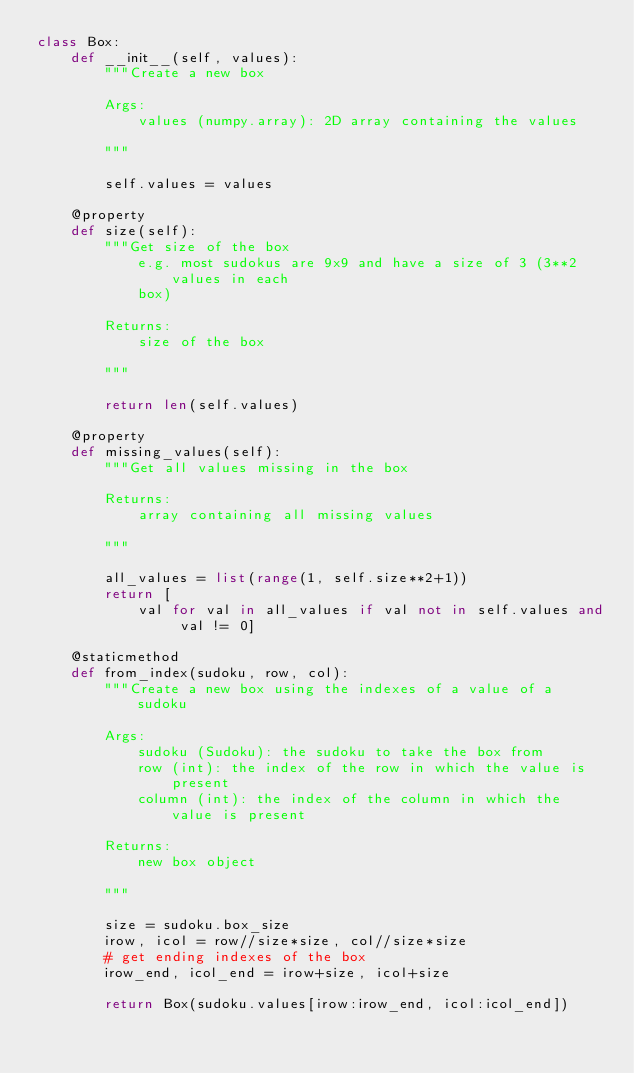<code> <loc_0><loc_0><loc_500><loc_500><_Python_>class Box:
    def __init__(self, values):
        """Create a new box

        Args:
            values (numpy.array): 2D array containing the values

        """

        self.values = values

    @property
    def size(self):
        """Get size of the box
            e.g. most sudokus are 9x9 and have a size of 3 (3**2 values in each
            box)

        Returns:
            size of the box

        """

        return len(self.values)

    @property
    def missing_values(self):
        """Get all values missing in the box

        Returns:
            array containing all missing values

        """

        all_values = list(range(1, self.size**2+1))
        return [
            val for val in all_values if val not in self.values and val != 0]

    @staticmethod
    def from_index(sudoku, row, col):
        """Create a new box using the indexes of a value of a sudoku

        Args:
            sudoku (Sudoku): the sudoku to take the box from
            row (int): the index of the row in which the value is present
            column (int): the index of the column in which the value is present

        Returns:
            new box object

        """

        size = sudoku.box_size
        irow, icol = row//size*size, col//size*size
        # get ending indexes of the box
        irow_end, icol_end = irow+size, icol+size

        return Box(sudoku.values[irow:irow_end, icol:icol_end])
</code> 